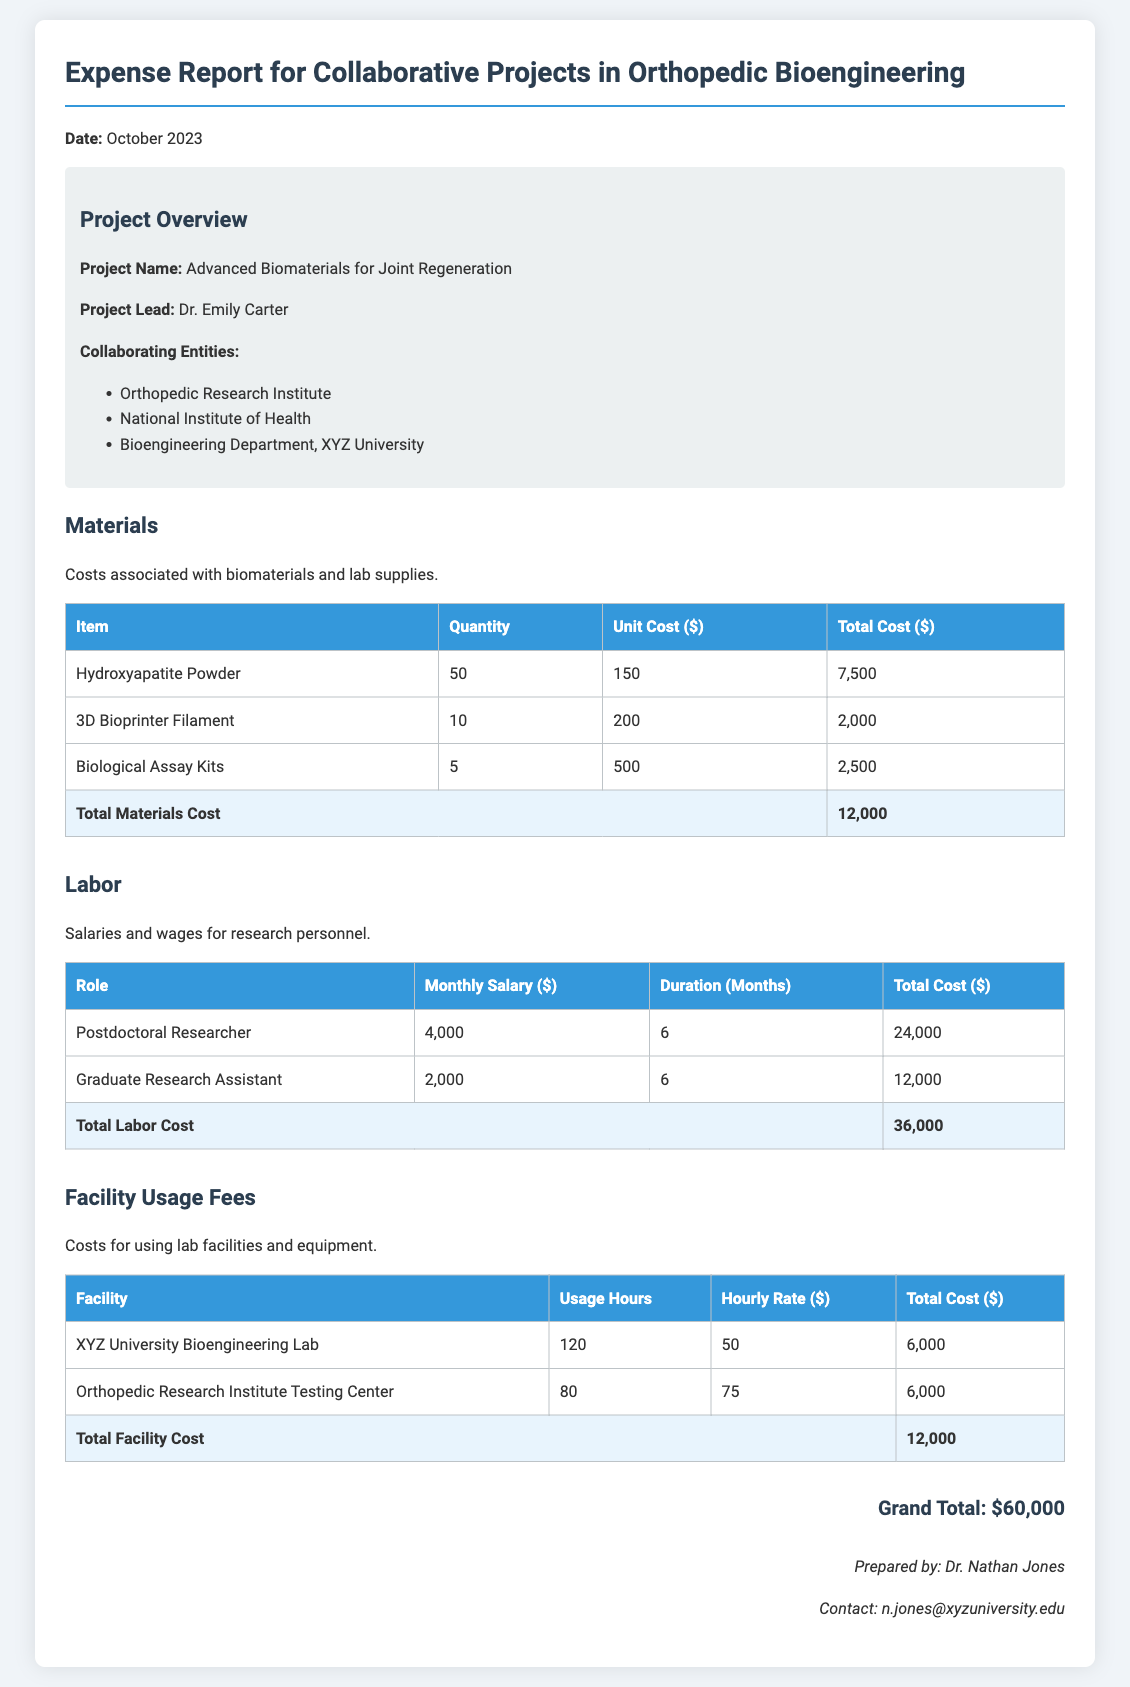what is the project name? The project name is stated under the project overview section of the document.
Answer: Advanced Biomaterials for Joint Regeneration who is the project lead? The project lead is also mentioned in the project overview section.
Answer: Dr. Emily Carter what is the total costs for materials? The total materials cost is calculated from the table under materials and summarized in the document.
Answer: 12,000 how many months was the postdoctoral researcher funded? The number of months is listed in the labor section of the document corresponding to the postdoctoral researcher.
Answer: 6 what is the hourly rate for the facility usage at XYZ University Bioengineering Lab? The hourly rate is detailed in the facility usage fees section of the document.
Answer: 50 what is the grand total of the expenses? The grand total is calculated at the end of the report, summarizing all expense categories.
Answer: 60,000 what is the total labor cost? The total labor cost is provided at the end of the labor section in the document.
Answer: 36,000 how many biological assay kits were purchased? This information can be found in the materials cost table under the item biological assay kits.
Answer: 5 who prepared this expense report? This information is listed at the bottom of the document.
Answer: Dr. Nathan Jones 